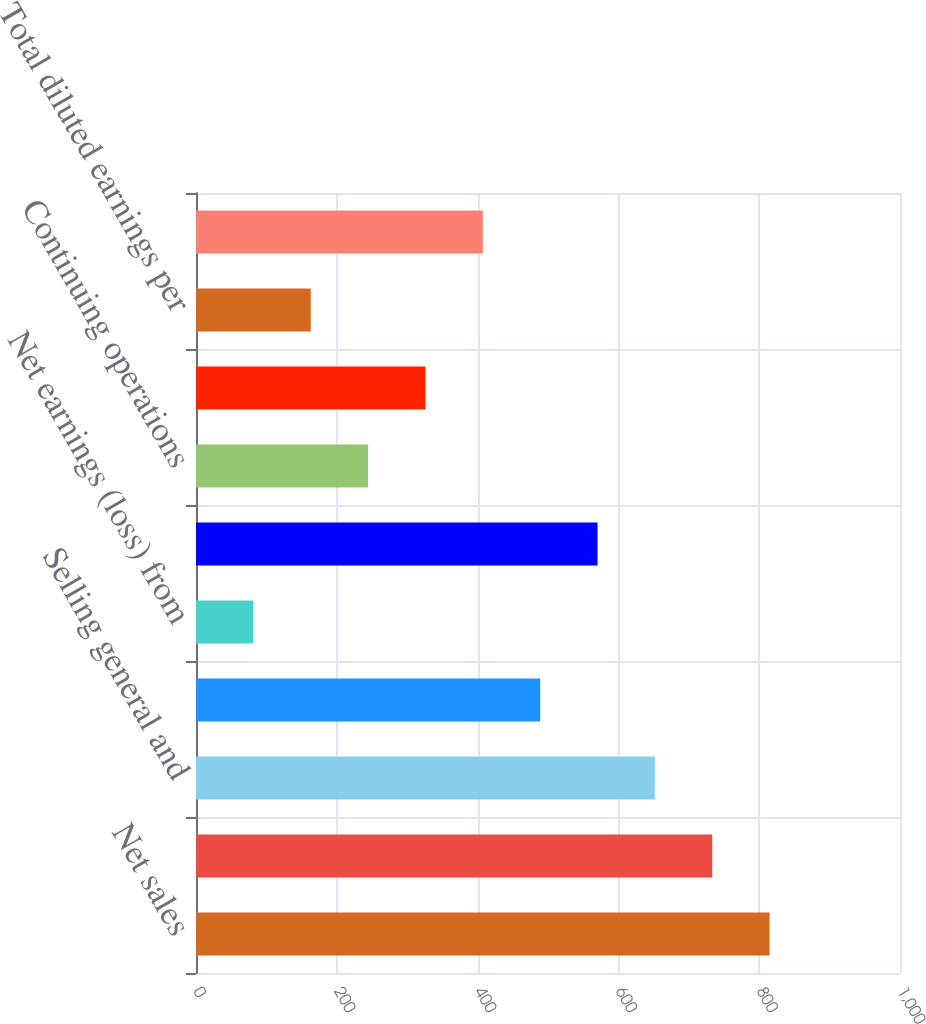Convert chart. <chart><loc_0><loc_0><loc_500><loc_500><bar_chart><fcel>Net sales<fcel>Gross profit<fcel>Selling general and<fcel>Net earnings from continuing<fcel>Net earnings (loss) from<fcel>Net earnings<fcel>Continuing operations<fcel>Total basic earnings per<fcel>Total diluted earnings per<fcel>Net earnings from discontinued<nl><fcel>814.74<fcel>733.27<fcel>651.8<fcel>488.86<fcel>81.51<fcel>570.33<fcel>244.45<fcel>325.92<fcel>162.98<fcel>407.39<nl></chart> 